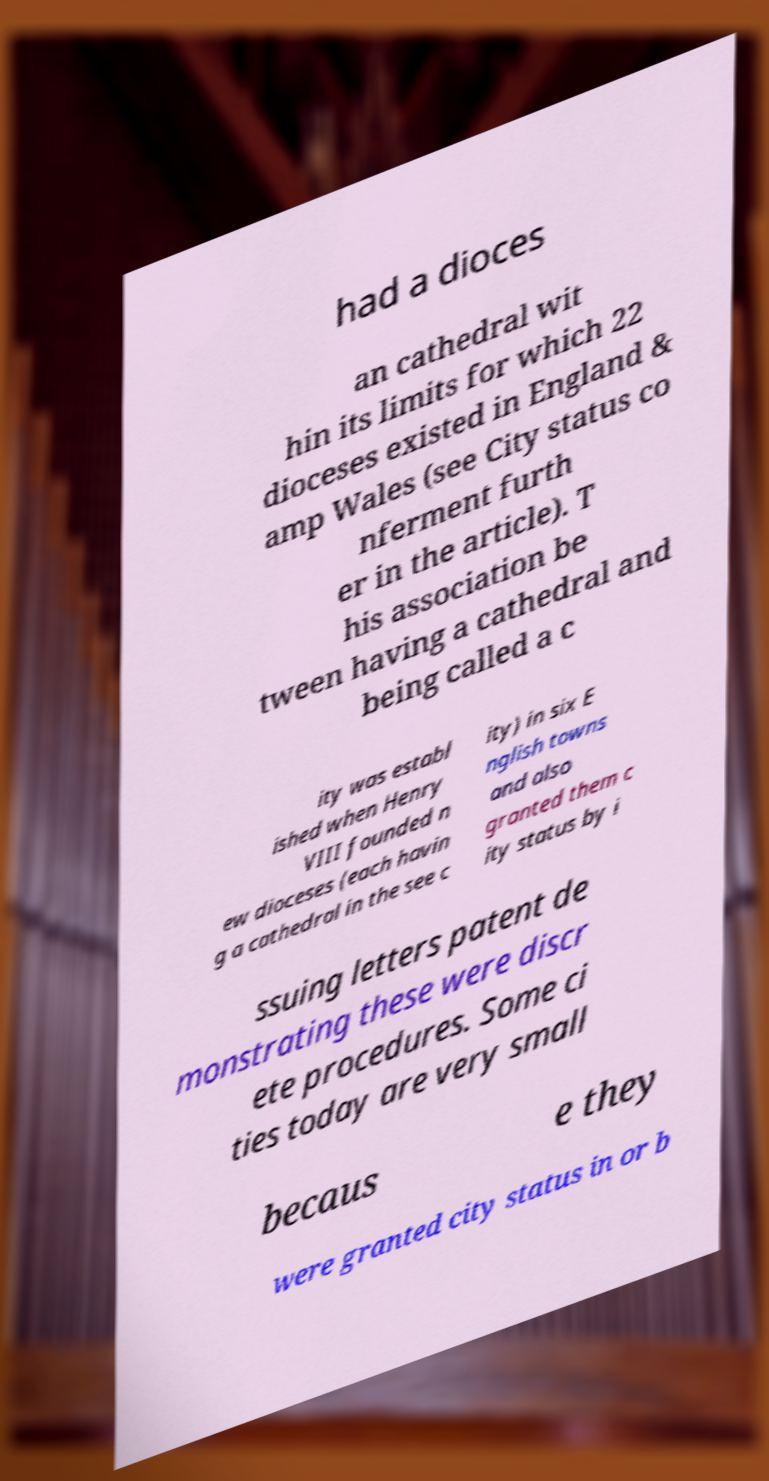Please read and relay the text visible in this image. What does it say? had a dioces an cathedral wit hin its limits for which 22 dioceses existed in England & amp Wales (see City status co nferment furth er in the article). T his association be tween having a cathedral and being called a c ity was establ ished when Henry VIII founded n ew dioceses (each havin g a cathedral in the see c ity) in six E nglish towns and also granted them c ity status by i ssuing letters patent de monstrating these were discr ete procedures. Some ci ties today are very small becaus e they were granted city status in or b 